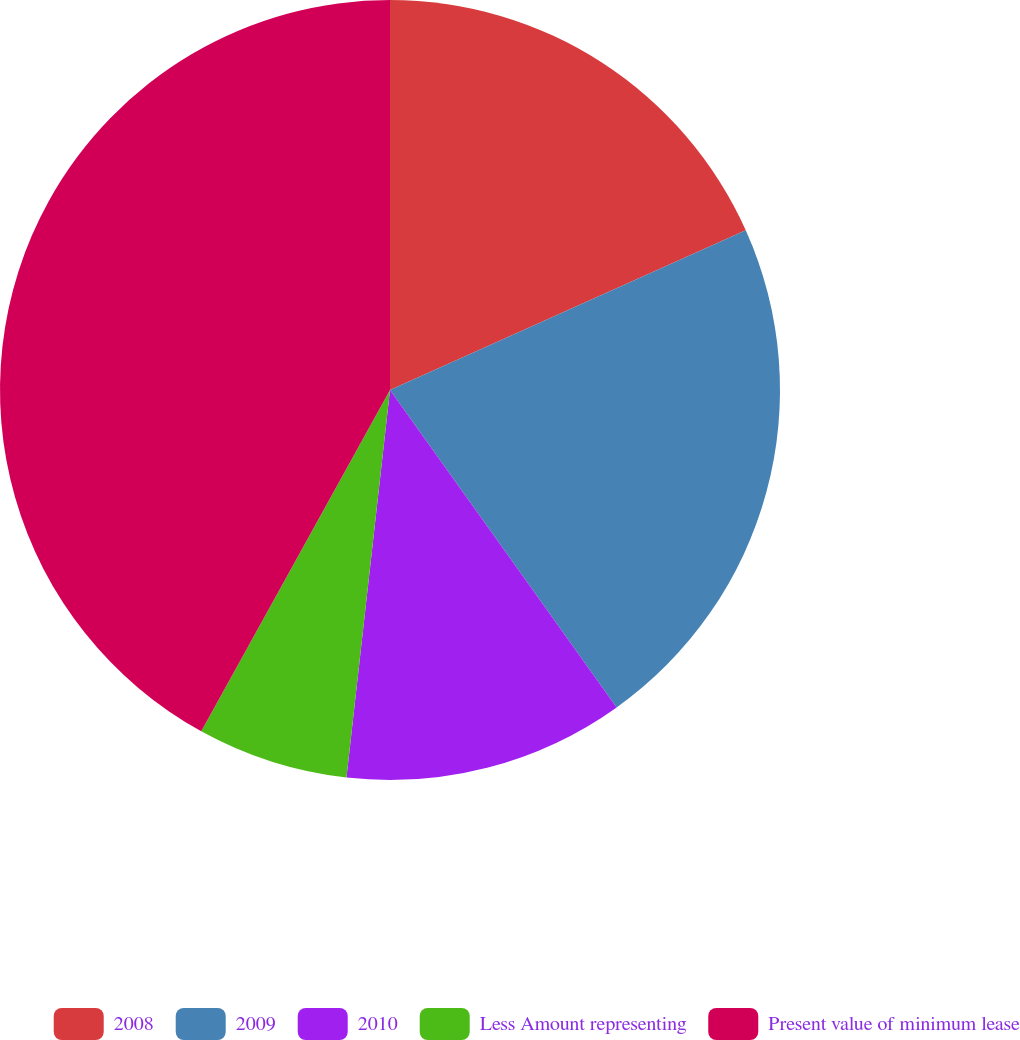Convert chart to OTSL. <chart><loc_0><loc_0><loc_500><loc_500><pie_chart><fcel>2008<fcel>2009<fcel>2010<fcel>Less Amount representing<fcel>Present value of minimum lease<nl><fcel>18.28%<fcel>21.85%<fcel>11.65%<fcel>6.26%<fcel>41.96%<nl></chart> 